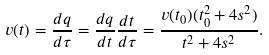Convert formula to latex. <formula><loc_0><loc_0><loc_500><loc_500>v ( t ) = \frac { d q } { d \tau } = \frac { d q } { d t } \frac { d t } { d \tau } = \frac { v ( t _ { 0 } ) ( t _ { 0 } ^ { 2 } + 4 s ^ { 2 } ) } { t ^ { 2 } + 4 s ^ { 2 } } .</formula> 